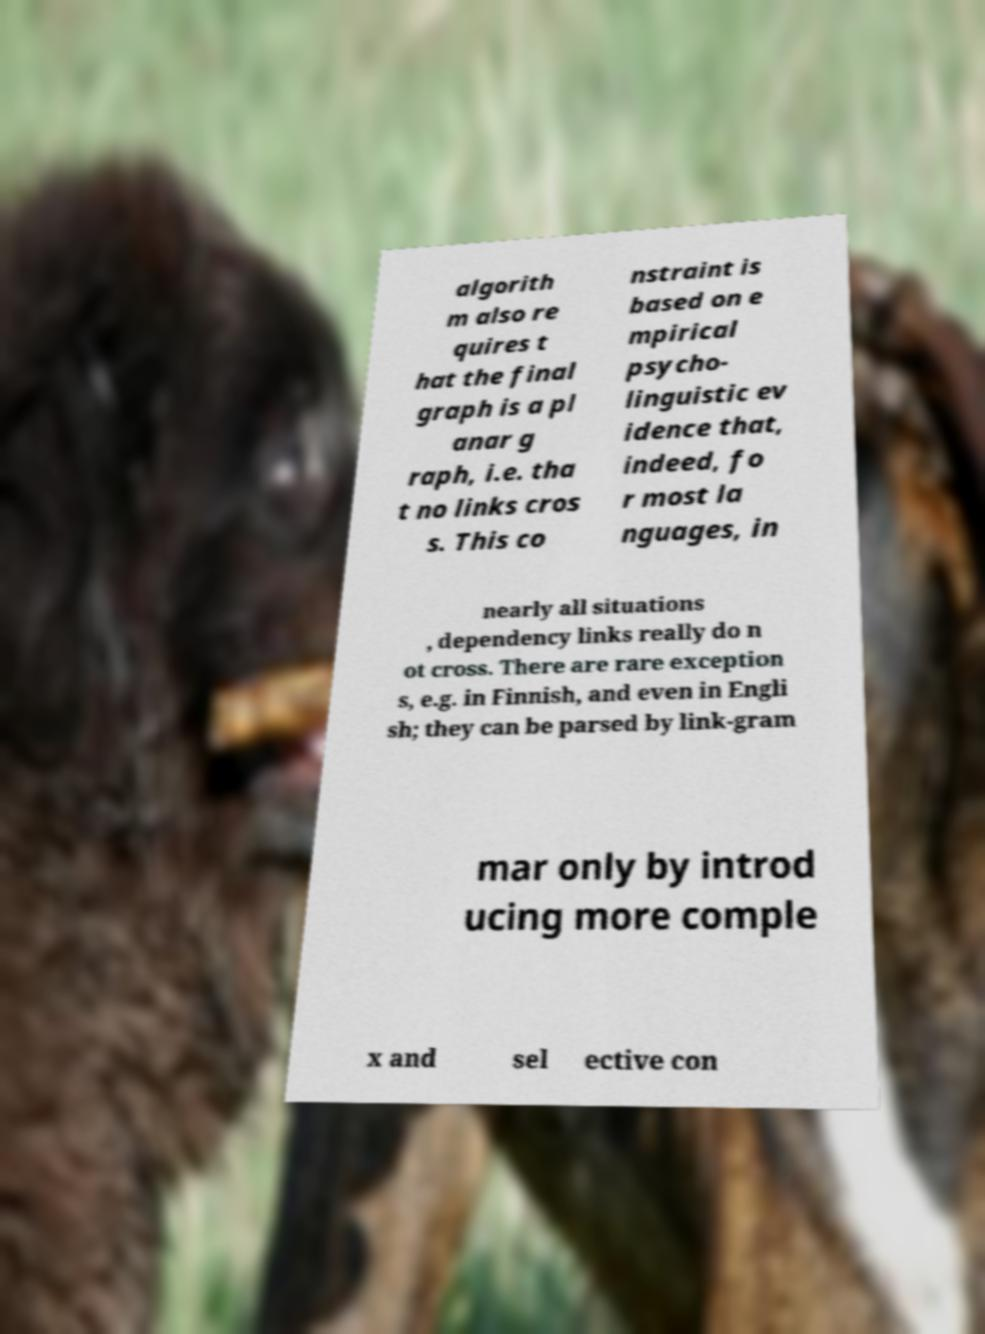What messages or text are displayed in this image? I need them in a readable, typed format. algorith m also re quires t hat the final graph is a pl anar g raph, i.e. tha t no links cros s. This co nstraint is based on e mpirical psycho- linguistic ev idence that, indeed, fo r most la nguages, in nearly all situations , dependency links really do n ot cross. There are rare exception s, e.g. in Finnish, and even in Engli sh; they can be parsed by link-gram mar only by introd ucing more comple x and sel ective con 